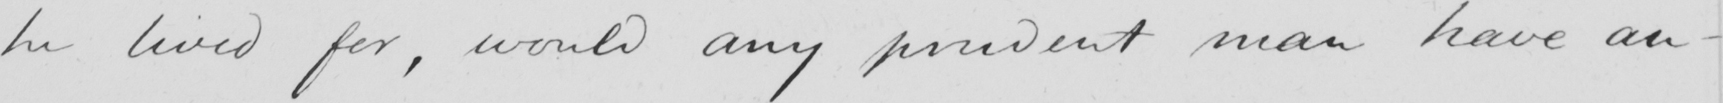Can you read and transcribe this handwriting? he lived for , would any prudent man have an 